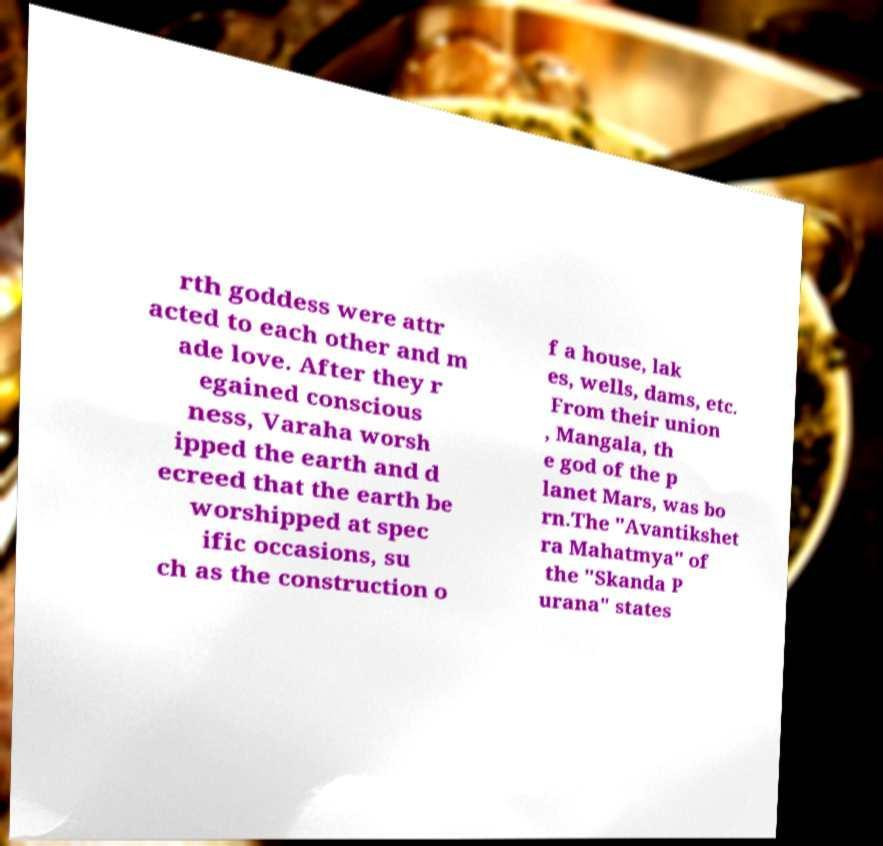Can you read and provide the text displayed in the image?This photo seems to have some interesting text. Can you extract and type it out for me? rth goddess were attr acted to each other and m ade love. After they r egained conscious ness, Varaha worsh ipped the earth and d ecreed that the earth be worshipped at spec ific occasions, su ch as the construction o f a house, lak es, wells, dams, etc. From their union , Mangala, th e god of the p lanet Mars, was bo rn.The "Avantikshet ra Mahatmya" of the "Skanda P urana" states 